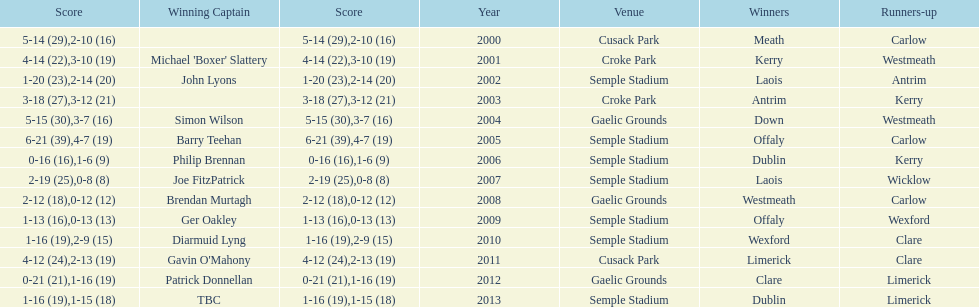How many times was carlow the runner-up? 3. 